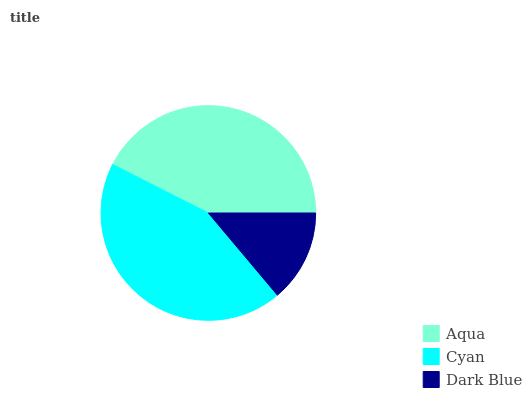Is Dark Blue the minimum?
Answer yes or no. Yes. Is Cyan the maximum?
Answer yes or no. Yes. Is Cyan the minimum?
Answer yes or no. No. Is Dark Blue the maximum?
Answer yes or no. No. Is Cyan greater than Dark Blue?
Answer yes or no. Yes. Is Dark Blue less than Cyan?
Answer yes or no. Yes. Is Dark Blue greater than Cyan?
Answer yes or no. No. Is Cyan less than Dark Blue?
Answer yes or no. No. Is Aqua the high median?
Answer yes or no. Yes. Is Aqua the low median?
Answer yes or no. Yes. Is Cyan the high median?
Answer yes or no. No. Is Cyan the low median?
Answer yes or no. No. 